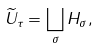<formula> <loc_0><loc_0><loc_500><loc_500>\widetilde { U } _ { \tau } = \bigsqcup _ { \sigma } H _ { \sigma } ,</formula> 